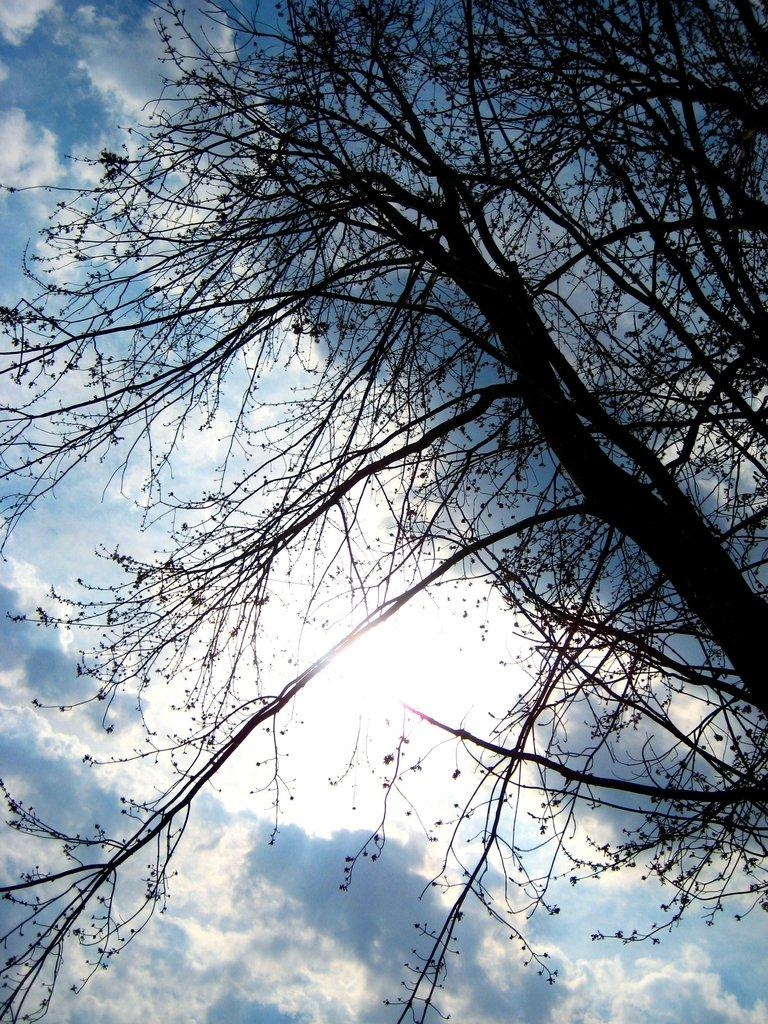What type of plant can be seen in the image? There is a tree in the image. What part of the natural environment is visible in the image? The sky is visible in the image. What can be seen in the sky in the image? Clouds are present in the sky. What invention is being used to create the smoke in the image? There is no smoke present in the image, so no invention is being used to create it. 